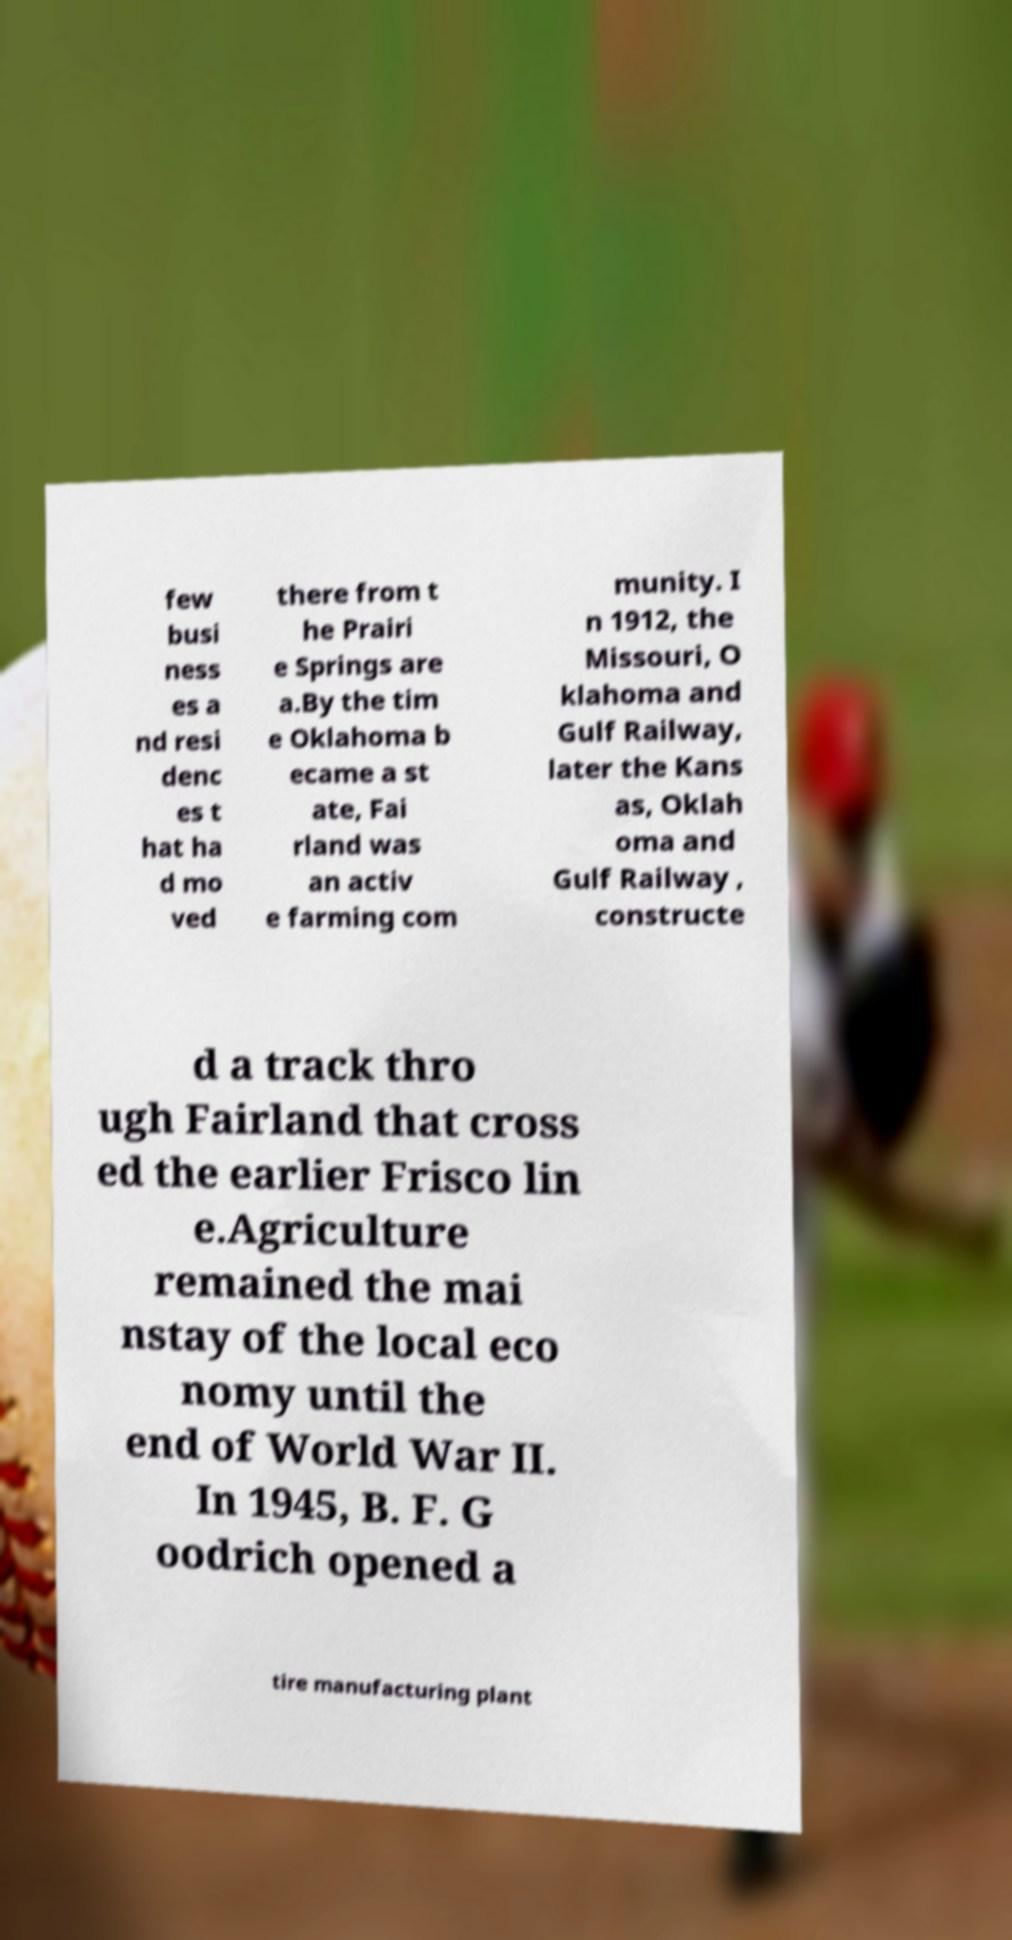There's text embedded in this image that I need extracted. Can you transcribe it verbatim? few busi ness es a nd resi denc es t hat ha d mo ved there from t he Prairi e Springs are a.By the tim e Oklahoma b ecame a st ate, Fai rland was an activ e farming com munity. I n 1912, the Missouri, O klahoma and Gulf Railway, later the Kans as, Oklah oma and Gulf Railway , constructe d a track thro ugh Fairland that cross ed the earlier Frisco lin e.Agriculture remained the mai nstay of the local eco nomy until the end of World War II. In 1945, B. F. G oodrich opened a tire manufacturing plant 